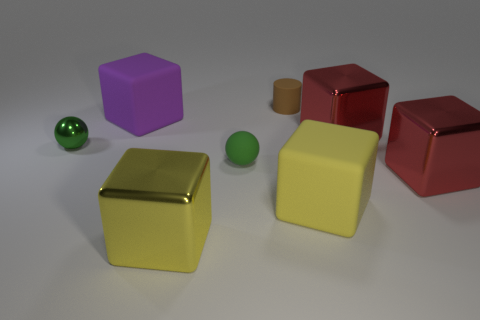Subtract all purple cubes. How many cubes are left? 4 Subtract 2 cubes. How many cubes are left? 3 Subtract all purple matte cubes. How many cubes are left? 4 Subtract all blue blocks. Subtract all red balls. How many blocks are left? 5 Add 1 large metallic things. How many objects exist? 9 Subtract all blocks. How many objects are left? 3 Add 3 large blocks. How many large blocks are left? 8 Add 3 matte cylinders. How many matte cylinders exist? 4 Subtract 0 red cylinders. How many objects are left? 8 Subtract all large rubber objects. Subtract all big red things. How many objects are left? 4 